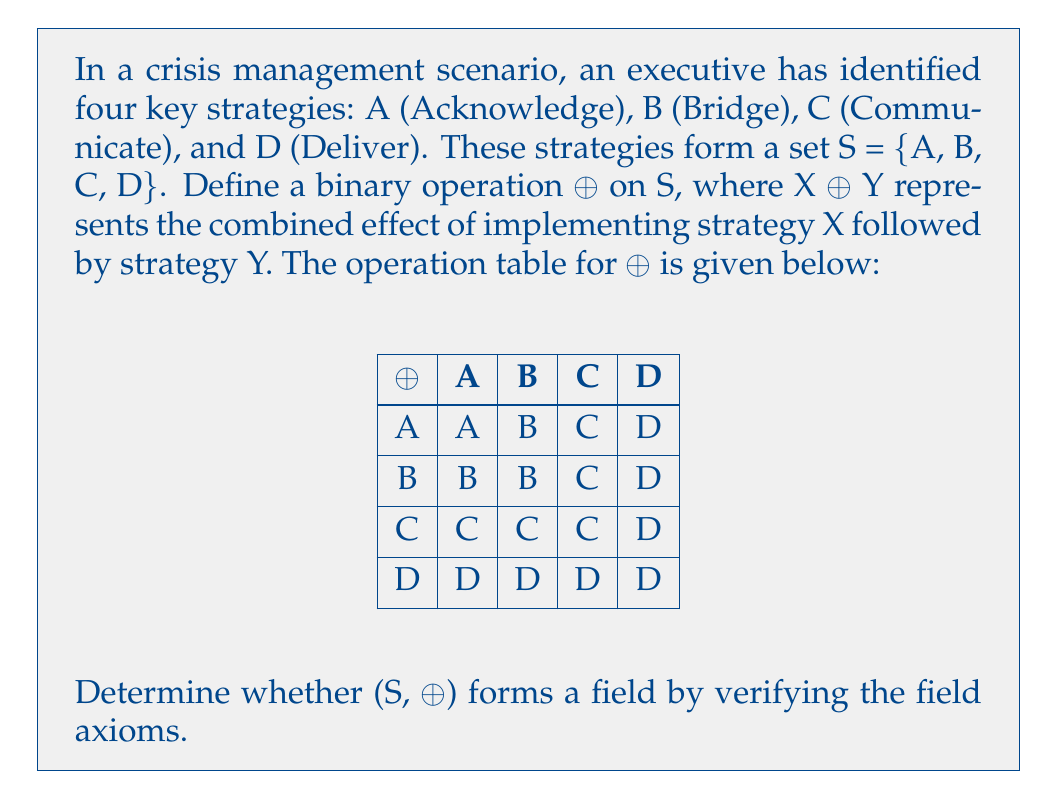Solve this math problem. To determine if (S, ⊕) forms a field, we need to verify all field axioms:

1. Closure: The operation table shows that for any X, Y ∈ S, X ⊕ Y ∈ S. So, closure is satisfied.

2. Associativity: We need to check if (X ⊕ Y) ⊕ Z = X ⊕ (Y ⊕ Z) for all X, Y, Z ∈ S. 
   By examining the table, we can see that the result always corresponds to the rightmost element in the operation. Therefore, associativity holds.

3. Commutativity: We need to check if X ⊕ Y = Y ⊕ X for all X, Y ∈ S.
   Counter-example: A ⊕ B = B, but B ⊕ A = B. Commutativity does not hold.

Since commutativity doesn't hold, (S, ⊕) cannot be a field. However, let's continue checking other properties:

4. Identity element: D acts as the identity element since X ⊕ D = D ⊕ X = X for all X ∈ S.

5. Inverse elements: For a field, each element should have an inverse.
   - A has no inverse: A ⊕ X = A only when X = A, but A ⊕ A = A ≠ D.
   - B, C, and D also lack inverses.

6. Distributivity: This property is not applicable as we only have one operation defined.

In conclusion, (S, ⊕) does not form a field because:
a) Commutativity does not hold
b) Not all elements have inverses
c) There's only one binary operation defined instead of two (addition and multiplication) required for a field
Answer: (S, ⊕) is not a field 